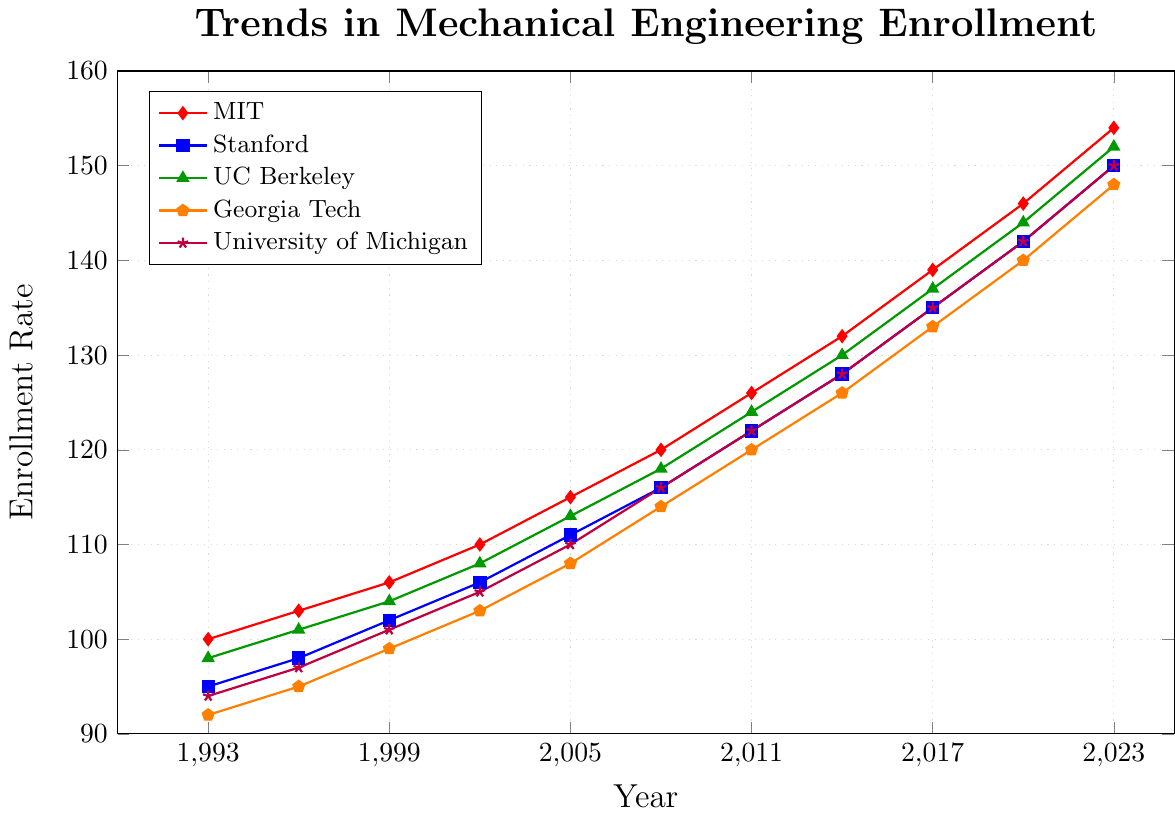what is the enrollment rate for MIT in 1993? By locating the data point corresponding to the year 1993 for the MIT line (in red) on the chart, we can see that it is at 100.
Answer: 100 Which university had the highest enrollment rate in 2023? To find this, we look at the data points for all universities in the year 2023. The values are MIT: 154, Stanford: 150, UC Berkeley: 152, Georgia Tech: 148, University of Michigan: 150. MIT had the highest enrollment rate.
Answer: MIT Compare the enrollment rates of Georgia Tech and University of Michigan in 2008. Which one is higher? Locate the data points for Georgia Tech and University of Michigan in 2008. Georgia Tech: 114, University of Michigan: 116. University of Michigan had a higher enrollment rate.
Answer: University of Michigan Calculate the average enrollment rate across all universities for the year 2014. In 2014, the enrollment rates are MIT: 132, Stanford: 128, UC Berkeley: 130, Georgia Tech: 126, University of Michigan: 128. The sum is 132 + 128 + 130 + 126 + 128 = 644. The average is 644 / 5 = 128.8
Answer: 128.8 Which university had a greater increase in enrollment rate between 1993 and 2005, Stanford or UC Berkeley? For Stanford, 2005's rate is 111 and 1993's rate is 95. Increase = 111 - 95 = 16. For UC Berkeley, 2005's rate is 113 and 1993's rate is 98. Increase = 113 - 98 = 15. Stanford had a greater increase.
Answer: Stanford At what year did University of Michigan pass the 120 enrollment rate threshold? By examining the data points for University of Michigan, the data point exceeds 120 first at the year 2011.
Answer: 2011 What is the total increase in enrollment rate for UC Berkeley from 1993 to 2023? UC Berkeley's enrollment rate in 1993 is 98 and in 2023 is 152. Total increase = 152 - 98 = 54.
Answer: 54 Identify the trend for MIT enrollment rates from 2017 to 2023. Is it increasing or decreasing? The enrollment rates for MIT from 2017 to 2023 are 139, 146, 154. Since the values are increasing over time, the trend is increasing.
Answer: Increasing 